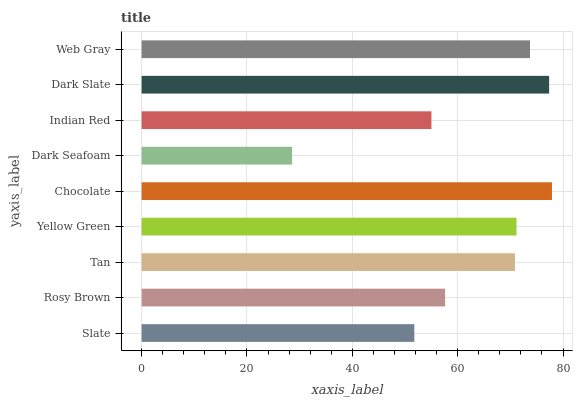Is Dark Seafoam the minimum?
Answer yes or no. Yes. Is Chocolate the maximum?
Answer yes or no. Yes. Is Rosy Brown the minimum?
Answer yes or no. No. Is Rosy Brown the maximum?
Answer yes or no. No. Is Rosy Brown greater than Slate?
Answer yes or no. Yes. Is Slate less than Rosy Brown?
Answer yes or no. Yes. Is Slate greater than Rosy Brown?
Answer yes or no. No. Is Rosy Brown less than Slate?
Answer yes or no. No. Is Tan the high median?
Answer yes or no. Yes. Is Tan the low median?
Answer yes or no. Yes. Is Dark Seafoam the high median?
Answer yes or no. No. Is Dark Slate the low median?
Answer yes or no. No. 